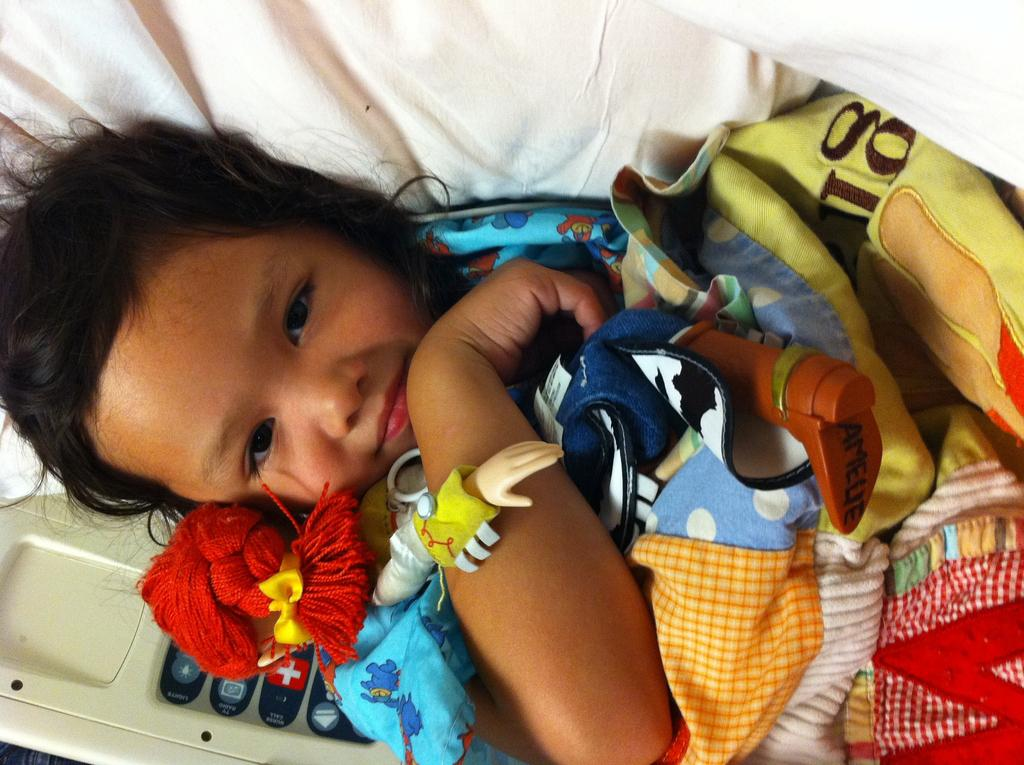<image>
Create a compact narrative representing the image presented. The bottom of the doll's boot reads Amelie. 